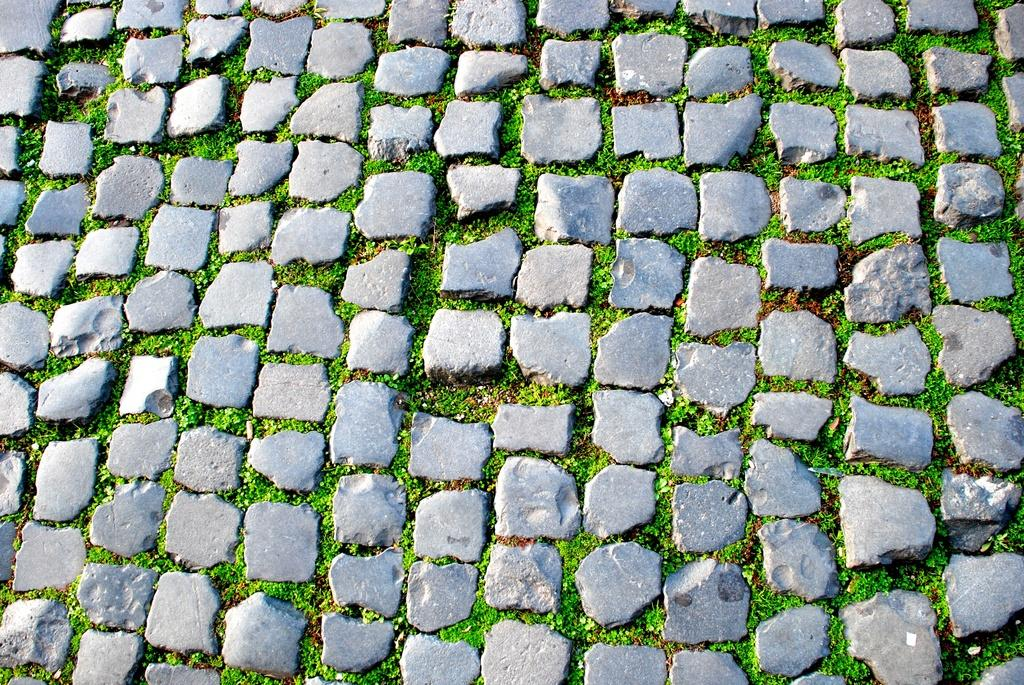What type of path is visible in the image? There is a stones path in the image. What can be seen in the middle of the stones path? Plant saplings are present in the middle of the stones path. What type of skin condition can be seen on the moon in the image? There is no moon present in the image, and therefore no skin condition can be observed. 